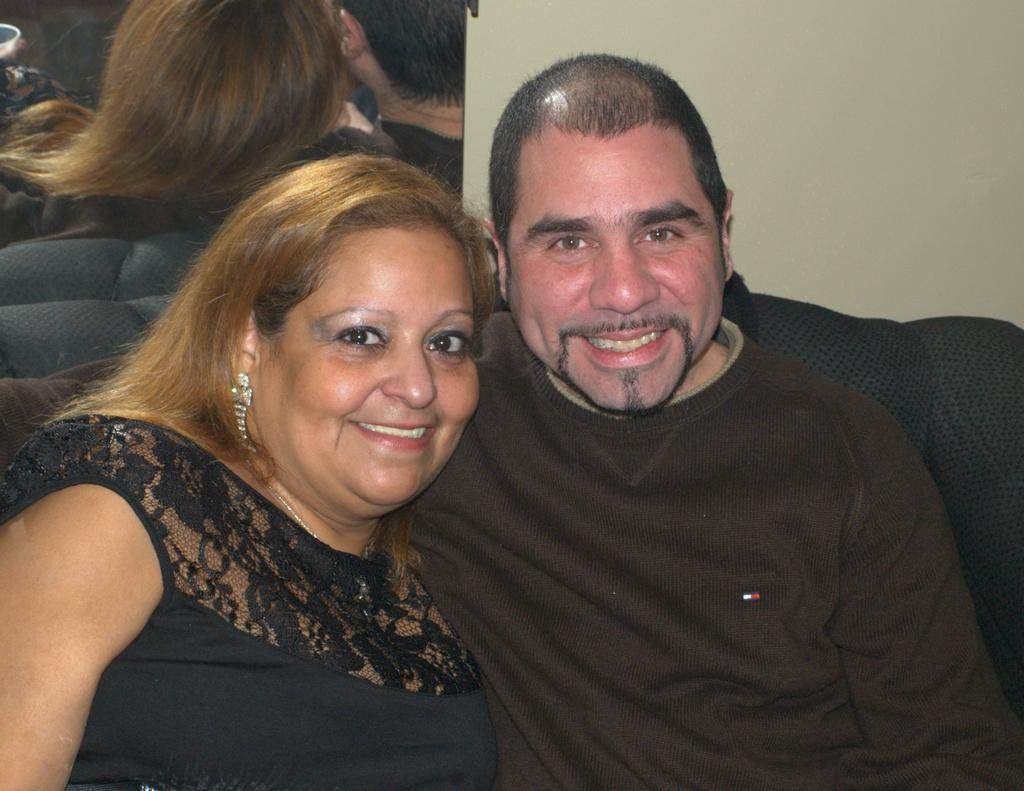How many people are present in the image? There are two people, a woman and a man, present in the image. What are the people wearing in the image? The woman and man are both wearing black color dress. What expressions do the people have in the image? The woman and man are smiling in the image. What can be seen in the background of the image? There is a mirror in the background of the image. How is the mirror positioned in the image? The mirror is fixed to a wall. Can you see the reflection of the people in the mirror? Yes, the woman and man's reflection is visible in the mirror. How many ants can be seen on the lawyer's respect in the image? There are no ants or lawyers present in the image, so this question cannot be answered. 